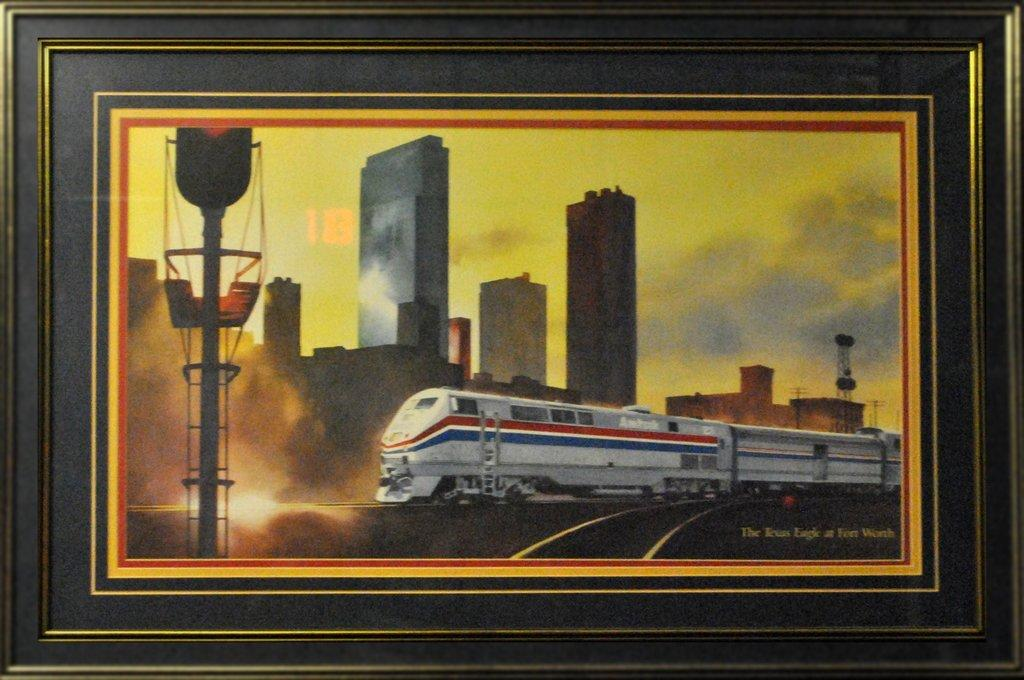What object is present in the image that contains a picture? There is a photo frame in the image that contains a picture. What is the subject of the picture within the photo frame? The picture within the photo frame contains a picture of a train. What elements are included in the picture of the train? The picture in the photo frame includes buildings and poles. What part of the natural environment can be seen in the picture within the photo frame? A: The sky is visible in the picture within the photo frame. What type of locket is hanging from the train in the picture within the photo frame? There is no locket present in the image, as the main object is a photo frame containing a picture of a train. 